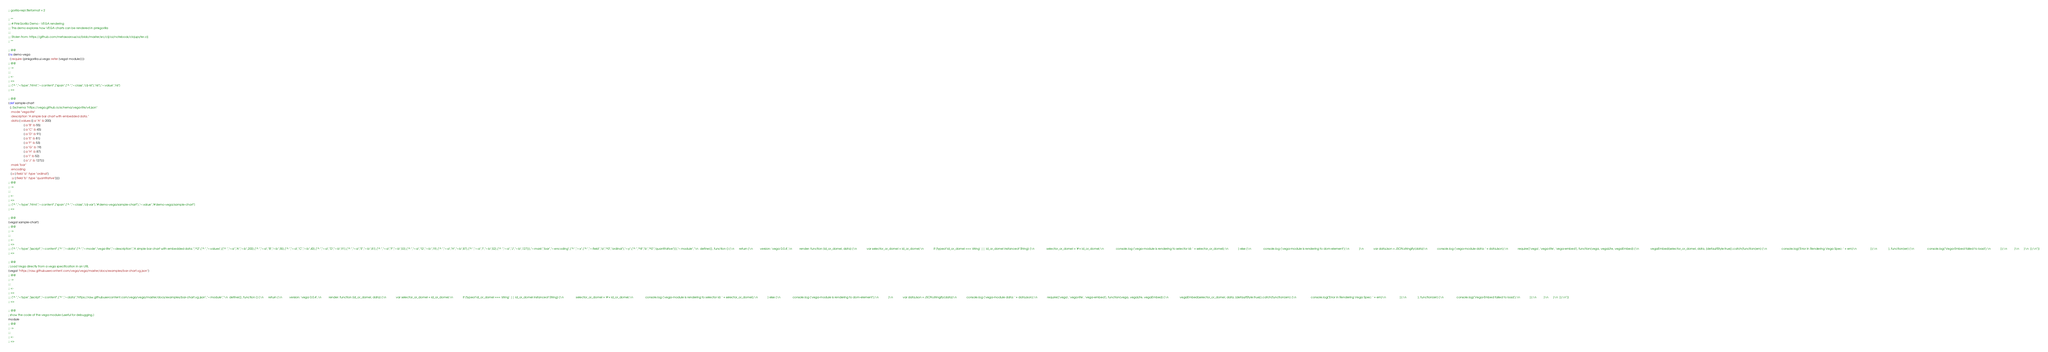Convert code to text. <code><loc_0><loc_0><loc_500><loc_500><_Clojure_>;; gorilla-repl.fileformat = 2

;; **
;;; # PinkGorilla Demo - VEGA rendering
;;; This demo explores how VEGA charts can be rendered in pinkgorilla
;;; 
;;; Stolen from: https://github.com/metasoarous/oz/blob/master/src/clj/oz/notebook/clojupyter.clj
;; **

;; @@
(ns demo-vega
  (:require [pinkgorilla.ui.vega :refer [vega! module]]))
;; @@
;; ->
;;; 
;; <-
;; =>
;;; ["^ ","~:type","html","~:content",["span",["^ ","~:class","clj-nil"],"nil"],"~:value","nil"]
;; <=

;; @@
(def sample-chart 
  {;:$schema "https://vega.github.io/schema/vega-lite/v4.json"
   :mode "vega-lite"
   :description "A simple bar chart with embedded data."
   :data {:values [{:a "A" :b 200} 
                   {:a "B" :b 55} 
                   {:a "C" :b 43}
                   {:a "D" :b 91} 
                   {:a "E" :b 81} 
                   {:a "F" :b 53}
                   {:a "G" :b 19} 
                   {:a "H" :b 87} 
                   {:a "I" :b 52} 
                   {:a "J" :b 127}]}
   :mark "bar" 
   :encoding 
   {:x {:field "a" :type "ordinal"}
    :y {:field "b" :type "quantitative"}}})
;; @@
;; ->
;;; 
;; <-
;; =>
;;; ["^ ","~:type","html","~:content",["span",["^ ","~:class","clj-var"],"#'demo-vega/sample-chart"],"~:value","#'demo-vega/sample-chart"]
;; <=

;; @@
(vega! sample-chart)
;; @@
;; ->
;;; 
;; <-
;; =>
;;; ["^ ","~:type","jsscript","~:content",["^ ","~:data",["^ ","~:mode","vega-lite","~:description","A simple bar chart with embedded data.","^2",["^ ","~:values",[["^ ","~:a","A","~:b",200],["^ ","~:a","B","~:b",55],["^ ","~:a","C","~:b",43],["^ ","~:a","D","~:b",91],["^ ","~:a","E","~:b",81],["^ ","~:a","F","~:b",53],["^ ","~:a","G","~:b",19],["^ ","~:a","H","~:b",87],["^ ","~:a","I","~:b",52],["^ ","~:a","J","~:b",127]]],"~:mark","bar","~:encoding",["^ ","~:x",["^ ","~:field","a","^0","ordinal"],"~:y",["^ ","^8","b","^0","quantitative"]]],"~:module","\n  define([], function () {\n      return {\n         version: 'vega 0.0.4',\n         render: function (id_or_domel, data) {\n            var selector_or_domel = id_or_domel;\n            if (typeof id_or_domel === 'string' || id_or_domel instanceof String) {\n               selector_or_domel = '#'+ id_or_domel;\n               console.log ('vega-module is rendering to selector id: ' + selector_or_domel);\n            } else {\n               console.log ('vega-module is rendering to dom-element');\n            }\n            var dataJson = JSON.stringify(data)\n            console.log ('vega-module data: ' + dataJson);\n            require(['vega', 'vega-lite', 'vega-embed'], function(vega, vegaLite, vegaEmbed) {\n              vegaEmbed(selector_or_domel, data, {defaultStyle:true}).catch(function(em) {\n                  console.log('Error in Rendering Vega Spec: ' + em)\n                 });\n              }, function(err) {\n                console.log('Vega-Embed failed to load');\n            });\n         }\n      }\n  });\n"]]
;; <=

;; @@
; Load Vega directly from a vega specification in an URL
(vega! "https://raw.githubusercontent.com/vega/vega/master/docs/examples/bar-chart.vg.json")  
;; @@
;; ->
;;; 
;; <-
;; =>
;;; ["^ ","~:type","jsscript","~:content",["^ ","~:data","https://raw.githubusercontent.com/vega/vega/master/docs/examples/bar-chart.vg.json","~:module","\n  define([], function () {\n      return {\n         version: 'vega 0.0.4',\n         render: function (id_or_domel, data) {\n            var selector_or_domel = id_or_domel;\n            if (typeof id_or_domel === 'string' || id_or_domel instanceof String) {\n               selector_or_domel = '#'+ id_or_domel;\n               console.log ('vega-module is rendering to selector id: ' + selector_or_domel);\n            } else {\n               console.log ('vega-module is rendering to dom-element');\n            }\n            var dataJson = JSON.stringify(data)\n            console.log ('vega-module data: ' + dataJson);\n            require(['vega', 'vega-lite', 'vega-embed'], function(vega, vegaLite, vegaEmbed) {\n              vegaEmbed(selector_or_domel, data, {defaultStyle:true}).catch(function(em) {\n                  console.log('Error in Rendering Vega Spec: ' + em)\n                 });\n              }, function(err) {\n                console.log('Vega-Embed failed to load');\n            });\n         }\n      }\n  });\n"]]
;; <=

;; @@
; show the code of the vega module (useful for debugging.)
module
;; @@
;; ->
;;; 
;; <-
;; =></code> 